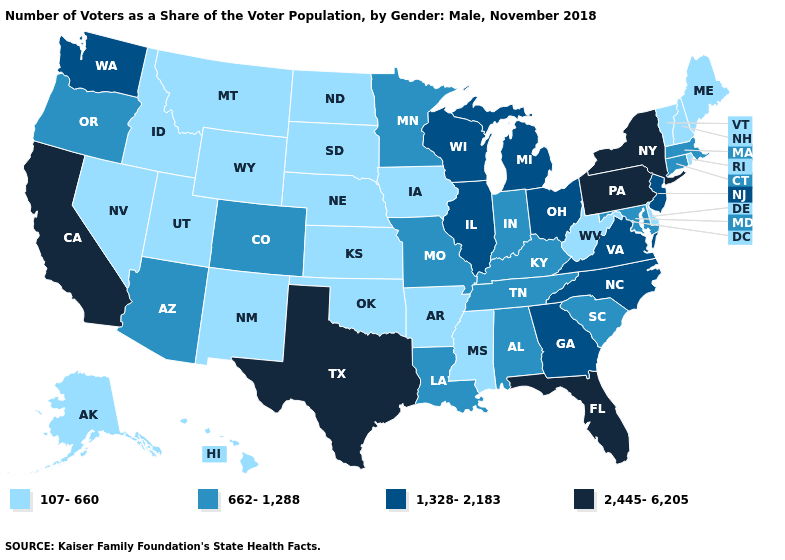What is the lowest value in the South?
Write a very short answer. 107-660. What is the lowest value in states that border North Carolina?
Short answer required. 662-1,288. Name the states that have a value in the range 2,445-6,205?
Give a very brief answer. California, Florida, New York, Pennsylvania, Texas. Does Louisiana have the lowest value in the USA?
Give a very brief answer. No. Does Louisiana have the lowest value in the USA?
Answer briefly. No. What is the lowest value in states that border Mississippi?
Be succinct. 107-660. Which states hav the highest value in the South?
Give a very brief answer. Florida, Texas. Name the states that have a value in the range 1,328-2,183?
Short answer required. Georgia, Illinois, Michigan, New Jersey, North Carolina, Ohio, Virginia, Washington, Wisconsin. What is the value of Arkansas?
Short answer required. 107-660. Name the states that have a value in the range 107-660?
Give a very brief answer. Alaska, Arkansas, Delaware, Hawaii, Idaho, Iowa, Kansas, Maine, Mississippi, Montana, Nebraska, Nevada, New Hampshire, New Mexico, North Dakota, Oklahoma, Rhode Island, South Dakota, Utah, Vermont, West Virginia, Wyoming. Is the legend a continuous bar?
Answer briefly. No. Among the states that border New York , which have the lowest value?
Concise answer only. Vermont. What is the value of North Dakota?
Short answer required. 107-660. Among the states that border Michigan , does Ohio have the highest value?
Quick response, please. Yes. 